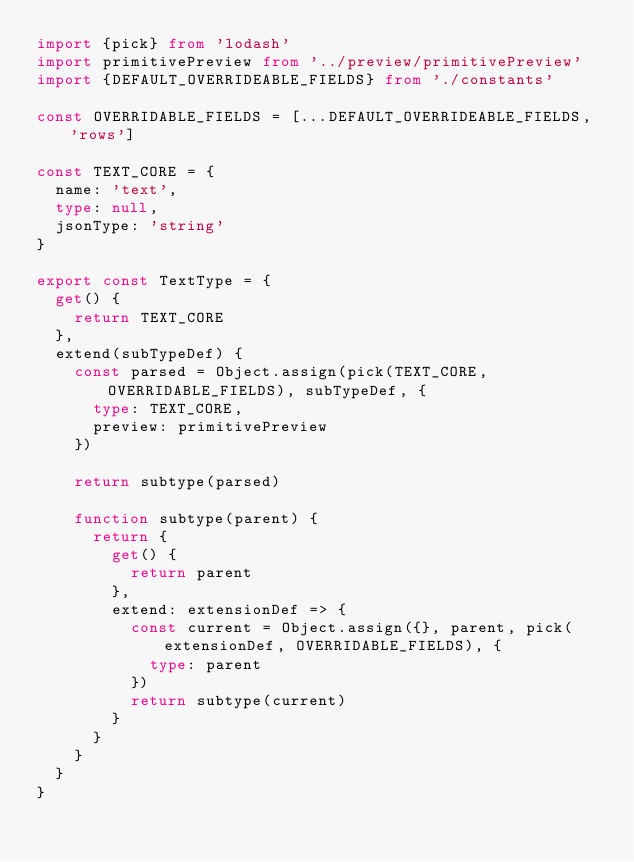<code> <loc_0><loc_0><loc_500><loc_500><_TypeScript_>import {pick} from 'lodash'
import primitivePreview from '../preview/primitivePreview'
import {DEFAULT_OVERRIDEABLE_FIELDS} from './constants'

const OVERRIDABLE_FIELDS = [...DEFAULT_OVERRIDEABLE_FIELDS, 'rows']

const TEXT_CORE = {
  name: 'text',
  type: null,
  jsonType: 'string'
}

export const TextType = {
  get() {
    return TEXT_CORE
  },
  extend(subTypeDef) {
    const parsed = Object.assign(pick(TEXT_CORE, OVERRIDABLE_FIELDS), subTypeDef, {
      type: TEXT_CORE,
      preview: primitivePreview
    })

    return subtype(parsed)

    function subtype(parent) {
      return {
        get() {
          return parent
        },
        extend: extensionDef => {
          const current = Object.assign({}, parent, pick(extensionDef, OVERRIDABLE_FIELDS), {
            type: parent
          })
          return subtype(current)
        }
      }
    }
  }
}
</code> 